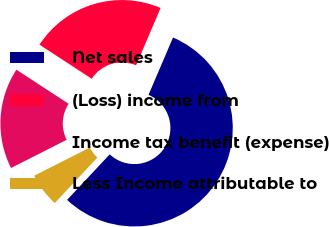<chart> <loc_0><loc_0><loc_500><loc_500><pie_chart><fcel>Net sales<fcel>(Loss) income from<fcel>Income tax benefit (expense)<fcel>Less Income attributable to<nl><fcel>55.54%<fcel>22.22%<fcel>16.67%<fcel>5.56%<nl></chart> 